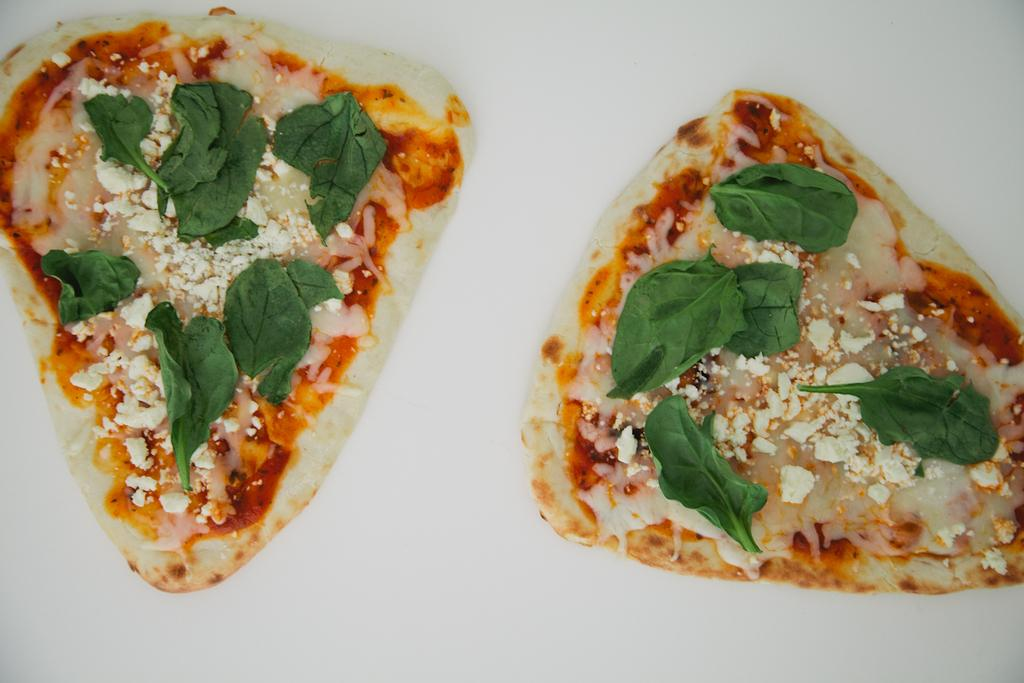What is the main subject of the image? The main subject of the image is food. On what surface is the food placed? The food is placed on a white surface. What colors can be seen in the food? The food has cream, green, and brown colors. How many trees can be seen supporting the food in the image? There are no trees present in the image, and they are not supporting the food. 